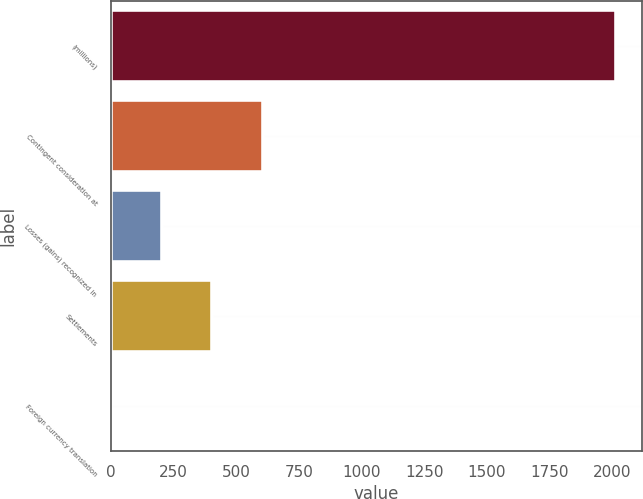<chart> <loc_0><loc_0><loc_500><loc_500><bar_chart><fcel>(millions)<fcel>Contingent consideration at<fcel>Losses (gains) recognized in<fcel>Settlements<fcel>Foreign currency translation<nl><fcel>2016<fcel>605.22<fcel>202.14<fcel>403.68<fcel>0.6<nl></chart> 